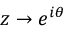Convert formula to latex. <formula><loc_0><loc_0><loc_500><loc_500>z \to e ^ { i \theta }</formula> 